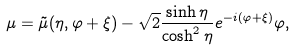<formula> <loc_0><loc_0><loc_500><loc_500>\mu = \tilde { \mu } ( \eta , \varphi + \xi ) - \sqrt { 2 } \frac { \sinh \eta } { \cosh ^ { 2 } \eta } e ^ { - i ( \varphi + \xi ) } \varphi ,</formula> 